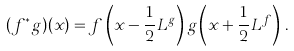<formula> <loc_0><loc_0><loc_500><loc_500>( f ^ { * } g ) ( x ) = f \left ( x - \frac { 1 } { 2 } L ^ { g } \right ) g \left ( x + \frac { 1 } { 2 } L ^ { f } \right ) \, .</formula> 